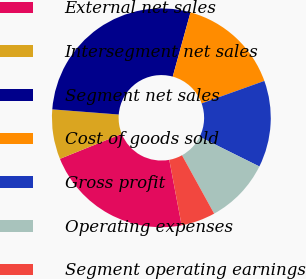<chart> <loc_0><loc_0><loc_500><loc_500><pie_chart><fcel>External net sales<fcel>Intersegment net sales<fcel>Segment net sales<fcel>Cost of goods sold<fcel>Gross profit<fcel>Operating expenses<fcel>Segment operating earnings<nl><fcel>21.85%<fcel>7.35%<fcel>28.06%<fcel>15.24%<fcel>12.81%<fcel>9.65%<fcel>5.05%<nl></chart> 